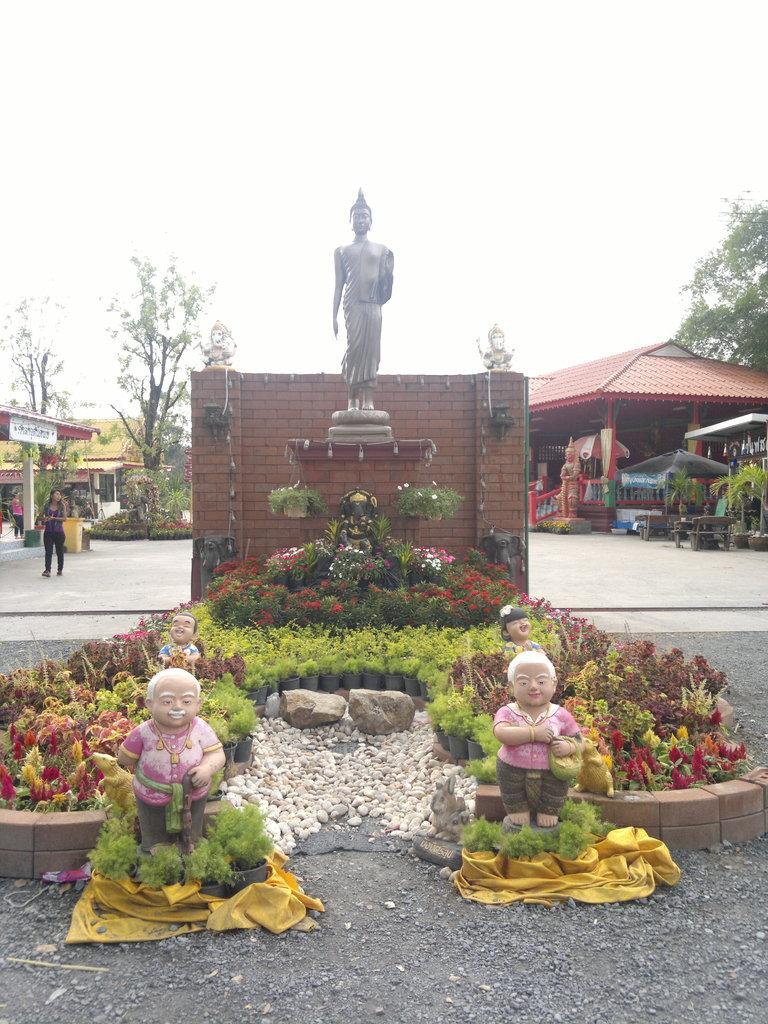What is the main subject in the center of the image? There is a statue in the center of the image. What else can be seen at the bottom of the image? There are statues and plants at the bottom of the image. What can be seen in the background of the image? There are buildings, trees, and the sky visible in the background of the image. Can you tell me where the brake is located in the image? There is no brake present in the image. Is there a river flowing through the image? There is no river visible in the image. 